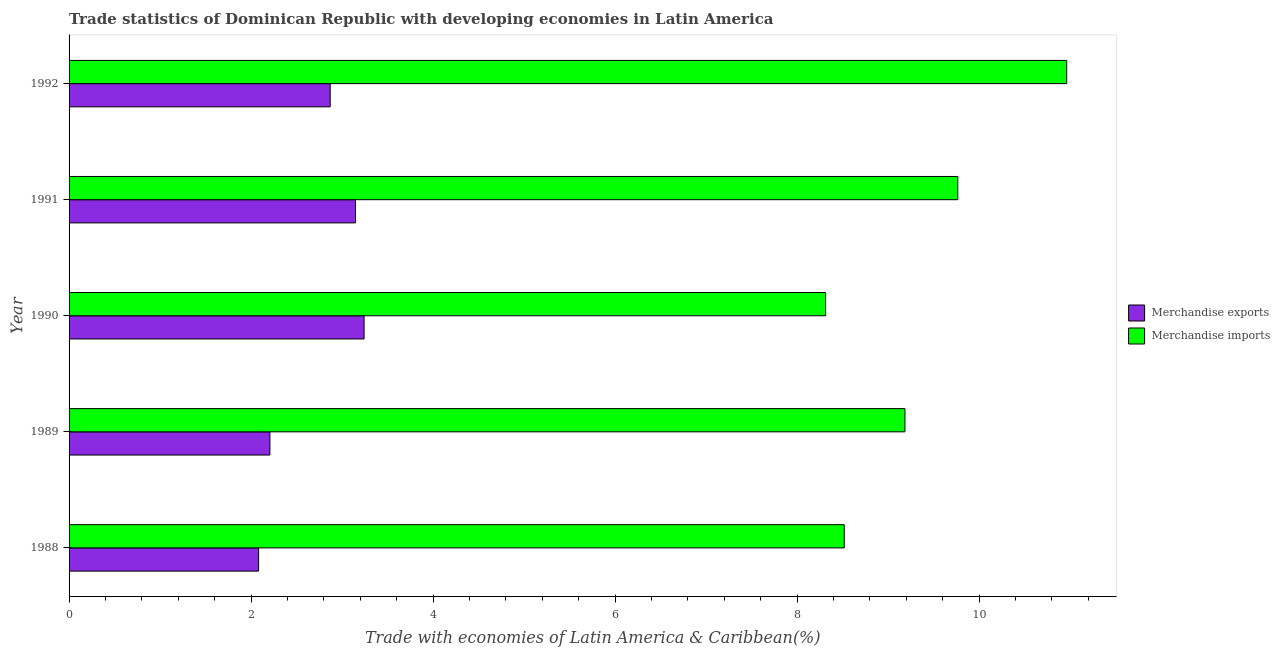Are the number of bars per tick equal to the number of legend labels?
Your answer should be very brief. Yes. How many bars are there on the 4th tick from the top?
Your answer should be very brief. 2. How many bars are there on the 5th tick from the bottom?
Offer a very short reply. 2. What is the label of the 2nd group of bars from the top?
Ensure brevity in your answer.  1991. What is the merchandise imports in 1988?
Ensure brevity in your answer.  8.52. Across all years, what is the maximum merchandise imports?
Offer a terse response. 10.96. Across all years, what is the minimum merchandise imports?
Your response must be concise. 8.31. What is the total merchandise imports in the graph?
Ensure brevity in your answer.  46.75. What is the difference between the merchandise exports in 1990 and that in 1991?
Keep it short and to the point. 0.09. What is the difference between the merchandise imports in 1989 and the merchandise exports in 1991?
Make the answer very short. 6.04. What is the average merchandise exports per year?
Offer a terse response. 2.71. In the year 1992, what is the difference between the merchandise exports and merchandise imports?
Ensure brevity in your answer.  -8.09. What is the ratio of the merchandise exports in 1988 to that in 1990?
Offer a terse response. 0.64. What is the difference between the highest and the second highest merchandise imports?
Provide a succinct answer. 1.2. What is the difference between the highest and the lowest merchandise exports?
Your response must be concise. 1.16. In how many years, is the merchandise exports greater than the average merchandise exports taken over all years?
Offer a very short reply. 3. Is the sum of the merchandise exports in 1990 and 1991 greater than the maximum merchandise imports across all years?
Provide a short and direct response. No. What does the 2nd bar from the top in 1991 represents?
Offer a very short reply. Merchandise exports. What does the 1st bar from the bottom in 1988 represents?
Offer a very short reply. Merchandise exports. How many bars are there?
Ensure brevity in your answer.  10. How many years are there in the graph?
Your answer should be compact. 5. What is the difference between two consecutive major ticks on the X-axis?
Your response must be concise. 2. Are the values on the major ticks of X-axis written in scientific E-notation?
Keep it short and to the point. No. Does the graph contain any zero values?
Ensure brevity in your answer.  No. Does the graph contain grids?
Offer a terse response. No. How many legend labels are there?
Provide a short and direct response. 2. How are the legend labels stacked?
Ensure brevity in your answer.  Vertical. What is the title of the graph?
Make the answer very short. Trade statistics of Dominican Republic with developing economies in Latin America. Does "Infant" appear as one of the legend labels in the graph?
Your response must be concise. No. What is the label or title of the X-axis?
Your response must be concise. Trade with economies of Latin America & Caribbean(%). What is the Trade with economies of Latin America & Caribbean(%) of Merchandise exports in 1988?
Make the answer very short. 2.08. What is the Trade with economies of Latin America & Caribbean(%) in Merchandise imports in 1988?
Your answer should be very brief. 8.52. What is the Trade with economies of Latin America & Caribbean(%) in Merchandise exports in 1989?
Your answer should be very brief. 2.21. What is the Trade with economies of Latin America & Caribbean(%) in Merchandise imports in 1989?
Provide a short and direct response. 9.19. What is the Trade with economies of Latin America & Caribbean(%) of Merchandise exports in 1990?
Offer a terse response. 3.24. What is the Trade with economies of Latin America & Caribbean(%) in Merchandise imports in 1990?
Your response must be concise. 8.31. What is the Trade with economies of Latin America & Caribbean(%) in Merchandise exports in 1991?
Provide a short and direct response. 3.15. What is the Trade with economies of Latin America & Caribbean(%) in Merchandise imports in 1991?
Offer a very short reply. 9.77. What is the Trade with economies of Latin America & Caribbean(%) in Merchandise exports in 1992?
Give a very brief answer. 2.87. What is the Trade with economies of Latin America & Caribbean(%) in Merchandise imports in 1992?
Your answer should be compact. 10.96. Across all years, what is the maximum Trade with economies of Latin America & Caribbean(%) in Merchandise exports?
Offer a very short reply. 3.24. Across all years, what is the maximum Trade with economies of Latin America & Caribbean(%) of Merchandise imports?
Your answer should be compact. 10.96. Across all years, what is the minimum Trade with economies of Latin America & Caribbean(%) of Merchandise exports?
Give a very brief answer. 2.08. Across all years, what is the minimum Trade with economies of Latin America & Caribbean(%) of Merchandise imports?
Provide a succinct answer. 8.31. What is the total Trade with economies of Latin America & Caribbean(%) in Merchandise exports in the graph?
Your answer should be compact. 13.55. What is the total Trade with economies of Latin America & Caribbean(%) of Merchandise imports in the graph?
Make the answer very short. 46.75. What is the difference between the Trade with economies of Latin America & Caribbean(%) in Merchandise exports in 1988 and that in 1989?
Offer a very short reply. -0.12. What is the difference between the Trade with economies of Latin America & Caribbean(%) of Merchandise imports in 1988 and that in 1989?
Provide a succinct answer. -0.67. What is the difference between the Trade with economies of Latin America & Caribbean(%) in Merchandise exports in 1988 and that in 1990?
Your answer should be compact. -1.16. What is the difference between the Trade with economies of Latin America & Caribbean(%) in Merchandise imports in 1988 and that in 1990?
Give a very brief answer. 0.2. What is the difference between the Trade with economies of Latin America & Caribbean(%) of Merchandise exports in 1988 and that in 1991?
Offer a very short reply. -1.06. What is the difference between the Trade with economies of Latin America & Caribbean(%) in Merchandise imports in 1988 and that in 1991?
Provide a short and direct response. -1.25. What is the difference between the Trade with economies of Latin America & Caribbean(%) of Merchandise exports in 1988 and that in 1992?
Your answer should be compact. -0.79. What is the difference between the Trade with economies of Latin America & Caribbean(%) in Merchandise imports in 1988 and that in 1992?
Your answer should be compact. -2.44. What is the difference between the Trade with economies of Latin America & Caribbean(%) in Merchandise exports in 1989 and that in 1990?
Keep it short and to the point. -1.04. What is the difference between the Trade with economies of Latin America & Caribbean(%) in Merchandise imports in 1989 and that in 1990?
Your response must be concise. 0.87. What is the difference between the Trade with economies of Latin America & Caribbean(%) of Merchandise exports in 1989 and that in 1991?
Provide a short and direct response. -0.94. What is the difference between the Trade with economies of Latin America & Caribbean(%) of Merchandise imports in 1989 and that in 1991?
Ensure brevity in your answer.  -0.58. What is the difference between the Trade with economies of Latin America & Caribbean(%) of Merchandise exports in 1989 and that in 1992?
Your response must be concise. -0.66. What is the difference between the Trade with economies of Latin America & Caribbean(%) of Merchandise imports in 1989 and that in 1992?
Make the answer very short. -1.78. What is the difference between the Trade with economies of Latin America & Caribbean(%) in Merchandise exports in 1990 and that in 1991?
Keep it short and to the point. 0.09. What is the difference between the Trade with economies of Latin America & Caribbean(%) in Merchandise imports in 1990 and that in 1991?
Ensure brevity in your answer.  -1.45. What is the difference between the Trade with economies of Latin America & Caribbean(%) of Merchandise exports in 1990 and that in 1992?
Offer a terse response. 0.37. What is the difference between the Trade with economies of Latin America & Caribbean(%) in Merchandise imports in 1990 and that in 1992?
Your answer should be very brief. -2.65. What is the difference between the Trade with economies of Latin America & Caribbean(%) of Merchandise exports in 1991 and that in 1992?
Keep it short and to the point. 0.28. What is the difference between the Trade with economies of Latin America & Caribbean(%) of Merchandise imports in 1991 and that in 1992?
Your answer should be compact. -1.2. What is the difference between the Trade with economies of Latin America & Caribbean(%) in Merchandise exports in 1988 and the Trade with economies of Latin America & Caribbean(%) in Merchandise imports in 1989?
Offer a very short reply. -7.1. What is the difference between the Trade with economies of Latin America & Caribbean(%) in Merchandise exports in 1988 and the Trade with economies of Latin America & Caribbean(%) in Merchandise imports in 1990?
Ensure brevity in your answer.  -6.23. What is the difference between the Trade with economies of Latin America & Caribbean(%) in Merchandise exports in 1988 and the Trade with economies of Latin America & Caribbean(%) in Merchandise imports in 1991?
Offer a terse response. -7.68. What is the difference between the Trade with economies of Latin America & Caribbean(%) of Merchandise exports in 1988 and the Trade with economies of Latin America & Caribbean(%) of Merchandise imports in 1992?
Ensure brevity in your answer.  -8.88. What is the difference between the Trade with economies of Latin America & Caribbean(%) in Merchandise exports in 1989 and the Trade with economies of Latin America & Caribbean(%) in Merchandise imports in 1990?
Your answer should be very brief. -6.11. What is the difference between the Trade with economies of Latin America & Caribbean(%) of Merchandise exports in 1989 and the Trade with economies of Latin America & Caribbean(%) of Merchandise imports in 1991?
Your answer should be very brief. -7.56. What is the difference between the Trade with economies of Latin America & Caribbean(%) of Merchandise exports in 1989 and the Trade with economies of Latin America & Caribbean(%) of Merchandise imports in 1992?
Make the answer very short. -8.76. What is the difference between the Trade with economies of Latin America & Caribbean(%) in Merchandise exports in 1990 and the Trade with economies of Latin America & Caribbean(%) in Merchandise imports in 1991?
Ensure brevity in your answer.  -6.52. What is the difference between the Trade with economies of Latin America & Caribbean(%) in Merchandise exports in 1990 and the Trade with economies of Latin America & Caribbean(%) in Merchandise imports in 1992?
Your response must be concise. -7.72. What is the difference between the Trade with economies of Latin America & Caribbean(%) of Merchandise exports in 1991 and the Trade with economies of Latin America & Caribbean(%) of Merchandise imports in 1992?
Make the answer very short. -7.82. What is the average Trade with economies of Latin America & Caribbean(%) in Merchandise exports per year?
Give a very brief answer. 2.71. What is the average Trade with economies of Latin America & Caribbean(%) in Merchandise imports per year?
Your response must be concise. 9.35. In the year 1988, what is the difference between the Trade with economies of Latin America & Caribbean(%) in Merchandise exports and Trade with economies of Latin America & Caribbean(%) in Merchandise imports?
Keep it short and to the point. -6.44. In the year 1989, what is the difference between the Trade with economies of Latin America & Caribbean(%) of Merchandise exports and Trade with economies of Latin America & Caribbean(%) of Merchandise imports?
Make the answer very short. -6.98. In the year 1990, what is the difference between the Trade with economies of Latin America & Caribbean(%) in Merchandise exports and Trade with economies of Latin America & Caribbean(%) in Merchandise imports?
Your answer should be compact. -5.07. In the year 1991, what is the difference between the Trade with economies of Latin America & Caribbean(%) of Merchandise exports and Trade with economies of Latin America & Caribbean(%) of Merchandise imports?
Give a very brief answer. -6.62. In the year 1992, what is the difference between the Trade with economies of Latin America & Caribbean(%) in Merchandise exports and Trade with economies of Latin America & Caribbean(%) in Merchandise imports?
Provide a short and direct response. -8.09. What is the ratio of the Trade with economies of Latin America & Caribbean(%) in Merchandise exports in 1988 to that in 1989?
Your answer should be compact. 0.94. What is the ratio of the Trade with economies of Latin America & Caribbean(%) of Merchandise imports in 1988 to that in 1989?
Your response must be concise. 0.93. What is the ratio of the Trade with economies of Latin America & Caribbean(%) in Merchandise exports in 1988 to that in 1990?
Your answer should be compact. 0.64. What is the ratio of the Trade with economies of Latin America & Caribbean(%) of Merchandise imports in 1988 to that in 1990?
Make the answer very short. 1.02. What is the ratio of the Trade with economies of Latin America & Caribbean(%) in Merchandise exports in 1988 to that in 1991?
Your answer should be very brief. 0.66. What is the ratio of the Trade with economies of Latin America & Caribbean(%) of Merchandise imports in 1988 to that in 1991?
Keep it short and to the point. 0.87. What is the ratio of the Trade with economies of Latin America & Caribbean(%) of Merchandise exports in 1988 to that in 1992?
Provide a succinct answer. 0.73. What is the ratio of the Trade with economies of Latin America & Caribbean(%) in Merchandise imports in 1988 to that in 1992?
Your response must be concise. 0.78. What is the ratio of the Trade with economies of Latin America & Caribbean(%) in Merchandise exports in 1989 to that in 1990?
Your response must be concise. 0.68. What is the ratio of the Trade with economies of Latin America & Caribbean(%) of Merchandise imports in 1989 to that in 1990?
Your response must be concise. 1.1. What is the ratio of the Trade with economies of Latin America & Caribbean(%) of Merchandise exports in 1989 to that in 1991?
Give a very brief answer. 0.7. What is the ratio of the Trade with economies of Latin America & Caribbean(%) of Merchandise imports in 1989 to that in 1991?
Offer a very short reply. 0.94. What is the ratio of the Trade with economies of Latin America & Caribbean(%) in Merchandise exports in 1989 to that in 1992?
Offer a very short reply. 0.77. What is the ratio of the Trade with economies of Latin America & Caribbean(%) in Merchandise imports in 1989 to that in 1992?
Your answer should be compact. 0.84. What is the ratio of the Trade with economies of Latin America & Caribbean(%) in Merchandise imports in 1990 to that in 1991?
Your answer should be compact. 0.85. What is the ratio of the Trade with economies of Latin America & Caribbean(%) of Merchandise exports in 1990 to that in 1992?
Your answer should be compact. 1.13. What is the ratio of the Trade with economies of Latin America & Caribbean(%) in Merchandise imports in 1990 to that in 1992?
Your answer should be compact. 0.76. What is the ratio of the Trade with economies of Latin America & Caribbean(%) in Merchandise exports in 1991 to that in 1992?
Provide a short and direct response. 1.1. What is the ratio of the Trade with economies of Latin America & Caribbean(%) in Merchandise imports in 1991 to that in 1992?
Your answer should be very brief. 0.89. What is the difference between the highest and the second highest Trade with economies of Latin America & Caribbean(%) of Merchandise exports?
Offer a very short reply. 0.09. What is the difference between the highest and the second highest Trade with economies of Latin America & Caribbean(%) of Merchandise imports?
Ensure brevity in your answer.  1.2. What is the difference between the highest and the lowest Trade with economies of Latin America & Caribbean(%) of Merchandise exports?
Make the answer very short. 1.16. What is the difference between the highest and the lowest Trade with economies of Latin America & Caribbean(%) in Merchandise imports?
Offer a terse response. 2.65. 